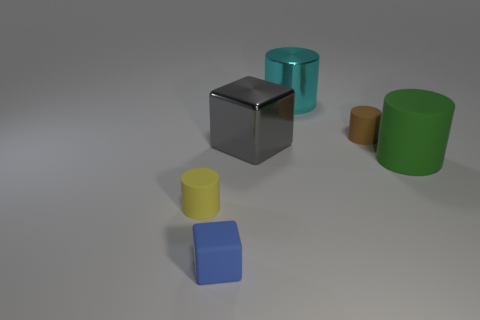Subtract all yellow rubber cylinders. How many cylinders are left? 3 Add 2 matte cylinders. How many objects exist? 8 Subtract all yellow cylinders. How many cylinders are left? 3 Subtract 2 blocks. How many blocks are left? 0 Subtract all cylinders. How many objects are left? 2 Subtract 1 brown cylinders. How many objects are left? 5 Subtract all purple cylinders. Subtract all gray blocks. How many cylinders are left? 4 Subtract all brown cylinders. How many blue blocks are left? 1 Subtract all brown rubber cylinders. Subtract all blue rubber things. How many objects are left? 4 Add 3 metal blocks. How many metal blocks are left? 4 